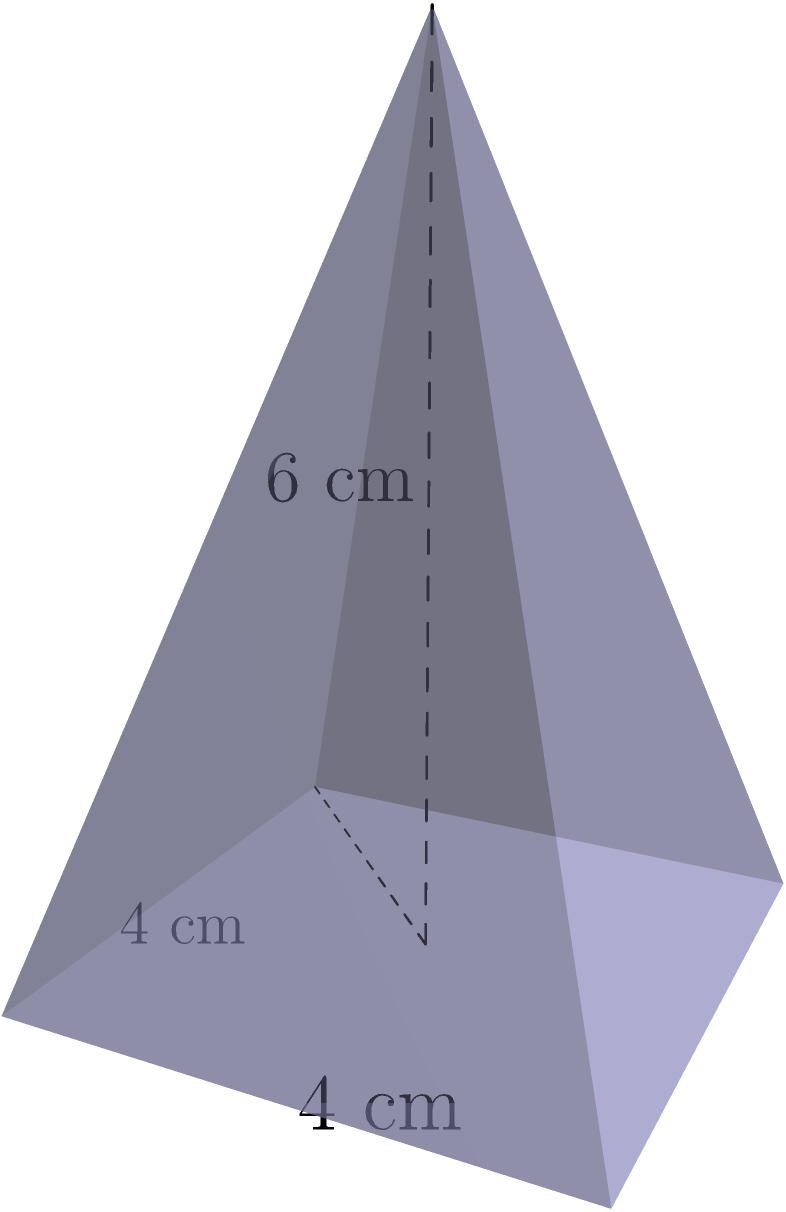As a karate instructor, you've been awarded a pyramid-shaped trophy for your contributions to martial arts. The trophy has a square base with sides measuring 4 cm, and its height is 6 cm. Calculate the volume of this trophy to determine the amount of material used in its construction. To calculate the volume of a pyramid, we use the formula:

$$V = \frac{1}{3} \times B \times h$$

Where:
$V$ = Volume
$B$ = Area of the base
$h$ = Height of the pyramid

Step 1: Calculate the area of the square base
$B = \text{side} \times \text{side} = 4 \text{ cm} \times 4 \text{ cm} = 16 \text{ cm}^2$

Step 2: Apply the volume formula
$$V = \frac{1}{3} \times B \times h$$
$$V = \frac{1}{3} \times 16 \text{ cm}^2 \times 6 \text{ cm}$$
$$V = \frac{96}{3} \text{ cm}^3$$
$$V = 32 \text{ cm}^3$$

Therefore, the volume of the pyramid-shaped trophy is 32 cubic centimeters.
Answer: $32 \text{ cm}^3$ 